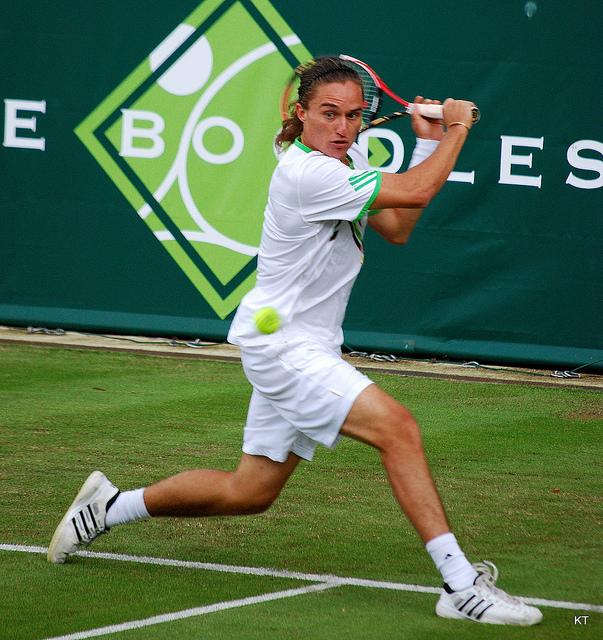What color is the ball?
Quick response, please. Green. What kind of tennis court is this?
Quick response, please. Grass. What language is on the side?
Short answer required. English. Is the person going to hit the ball?
Short answer required. Yes. 